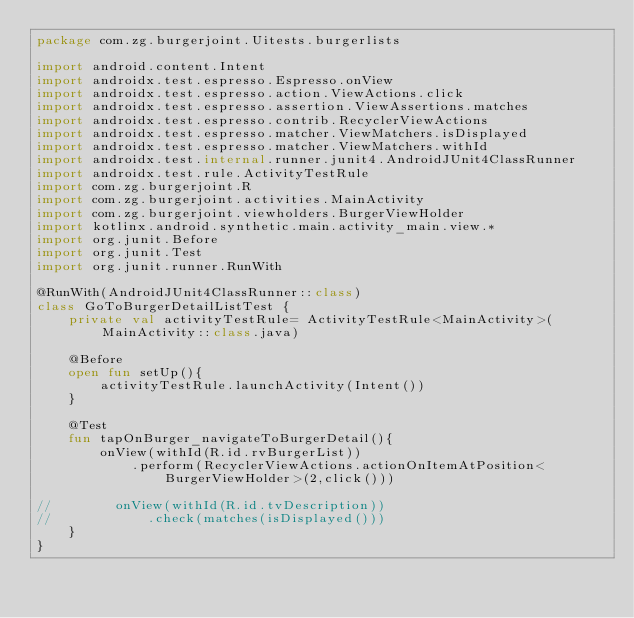Convert code to text. <code><loc_0><loc_0><loc_500><loc_500><_Kotlin_>package com.zg.burgerjoint.Uitests.burgerlists

import android.content.Intent
import androidx.test.espresso.Espresso.onView
import androidx.test.espresso.action.ViewActions.click
import androidx.test.espresso.assertion.ViewAssertions.matches
import androidx.test.espresso.contrib.RecyclerViewActions
import androidx.test.espresso.matcher.ViewMatchers.isDisplayed
import androidx.test.espresso.matcher.ViewMatchers.withId
import androidx.test.internal.runner.junit4.AndroidJUnit4ClassRunner
import androidx.test.rule.ActivityTestRule
import com.zg.burgerjoint.R
import com.zg.burgerjoint.activities.MainActivity
import com.zg.burgerjoint.viewholders.BurgerViewHolder
import kotlinx.android.synthetic.main.activity_main.view.*
import org.junit.Before
import org.junit.Test
import org.junit.runner.RunWith

@RunWith(AndroidJUnit4ClassRunner::class)
class GoToBurgerDetailListTest {
    private val activityTestRule= ActivityTestRule<MainActivity>(MainActivity::class.java)

    @Before
    open fun setUp(){
        activityTestRule.launchActivity(Intent())
    }

    @Test
    fun tapOnBurger_navigateToBurgerDetail(){
        onView(withId(R.id.rvBurgerList))
            .perform(RecyclerViewActions.actionOnItemAtPosition<BurgerViewHolder>(2,click()))

//        onView(withId(R.id.tvDescription))
//            .check(matches(isDisplayed()))
    }
}</code> 